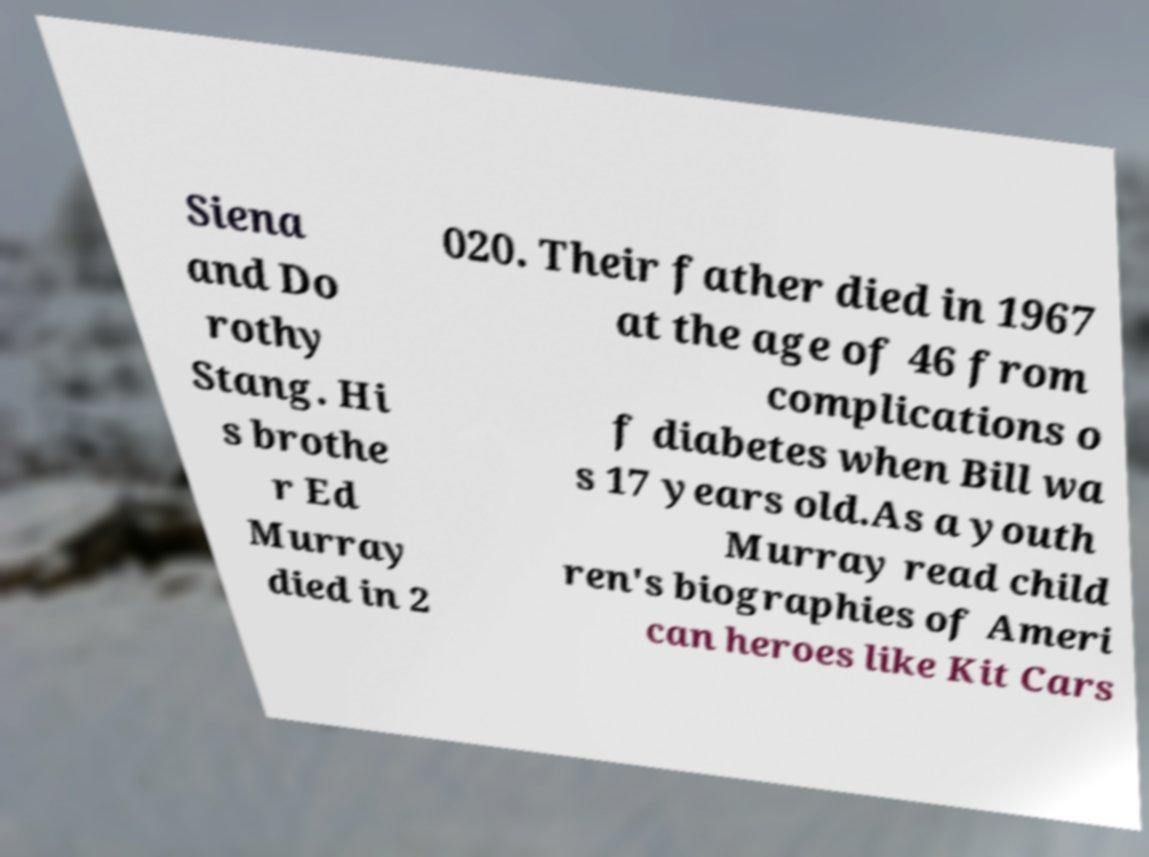I need the written content from this picture converted into text. Can you do that? Siena and Do rothy Stang. Hi s brothe r Ed Murray died in 2 020. Their father died in 1967 at the age of 46 from complications o f diabetes when Bill wa s 17 years old.As a youth Murray read child ren's biographies of Ameri can heroes like Kit Cars 